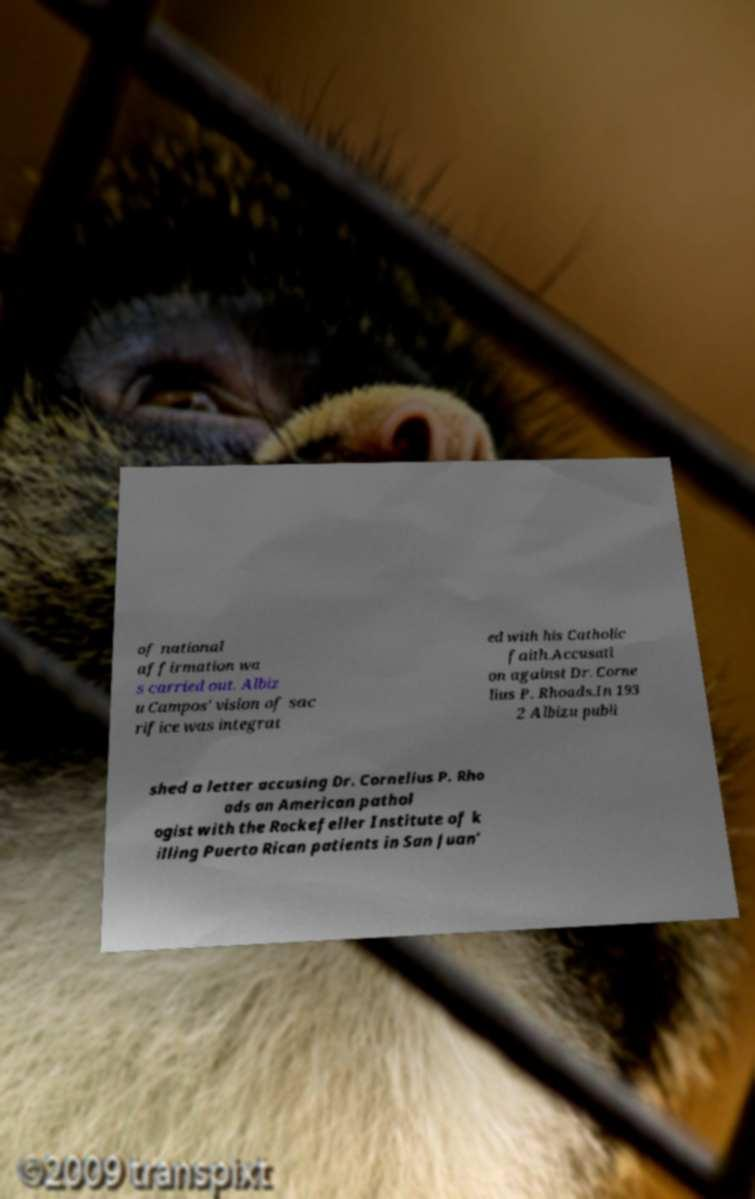I need the written content from this picture converted into text. Can you do that? of national affirmation wa s carried out. Albiz u Campos' vision of sac rifice was integrat ed with his Catholic faith.Accusati on against Dr. Corne lius P. Rhoads.In 193 2 Albizu publi shed a letter accusing Dr. Cornelius P. Rho ads an American pathol ogist with the Rockefeller Institute of k illing Puerto Rican patients in San Juan' 